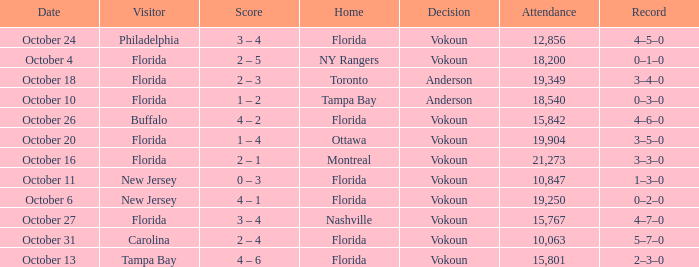What was the score on October 31? 2 – 4. 